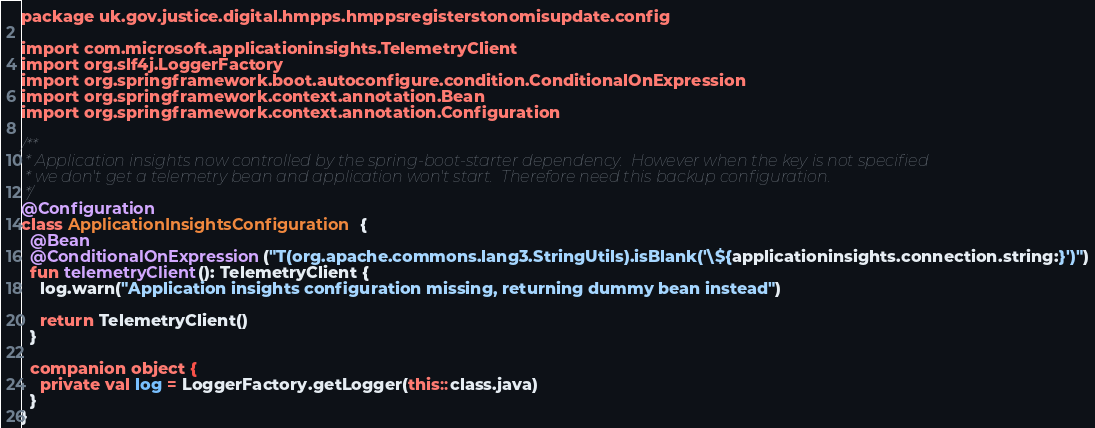Convert code to text. <code><loc_0><loc_0><loc_500><loc_500><_Kotlin_>package uk.gov.justice.digital.hmpps.hmppsregisterstonomisupdate.config

import com.microsoft.applicationinsights.TelemetryClient
import org.slf4j.LoggerFactory
import org.springframework.boot.autoconfigure.condition.ConditionalOnExpression
import org.springframework.context.annotation.Bean
import org.springframework.context.annotation.Configuration

/**
 * Application insights now controlled by the spring-boot-starter dependency.  However when the key is not specified
 * we don't get a telemetry bean and application won't start.  Therefore need this backup configuration.
 */
@Configuration
class ApplicationInsightsConfiguration {
  @Bean
  @ConditionalOnExpression("T(org.apache.commons.lang3.StringUtils).isBlank('\${applicationinsights.connection.string:}')")
  fun telemetryClient(): TelemetryClient {
    log.warn("Application insights configuration missing, returning dummy bean instead")

    return TelemetryClient()
  }

  companion object {
    private val log = LoggerFactory.getLogger(this::class.java)
  }
}
</code> 